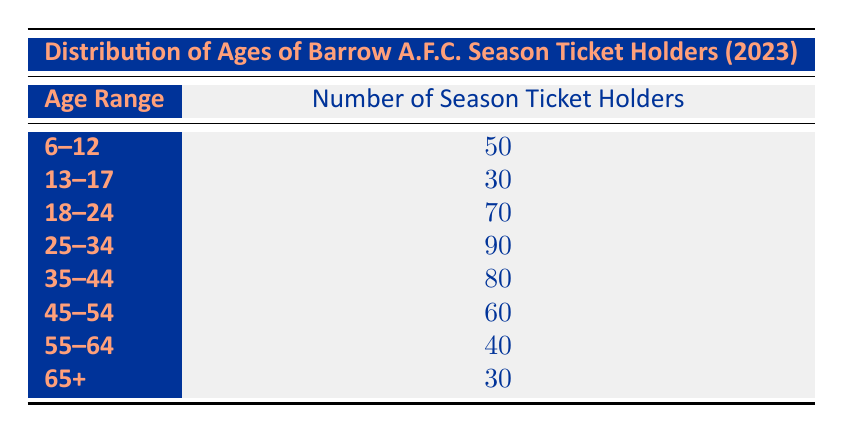What is the total number of season ticket holders aged 25-34? The table indicates that there are 90 season ticket holders in the age range of 25-34. You can find this information directly listed under that age range.
Answer: 90 Which age range has the lowest number of season ticket holders? By reviewing the table, the age range 13-17 has 30 season ticket holders, which is the smallest amount compared to the other age ranges provided.
Answer: 13-17 What is the total number of season ticket holders across all age ranges? To find the total, we add the number of season ticket holders in each age range: 50 + 30 + 70 + 90 + 80 + 60 + 40 + 30 = 450. So, the total number of season ticket holders is 450.
Answer: 450 Is there an equal number of season ticket holders in the age ranges 65+ and 13-17? The table shows that there are 30 season ticket holders in both the 65+ and 13-17 age ranges. Therefore, it is true that they have an equal number of ticket holders.
Answer: Yes What percentage of season ticket holders are aged 55-64 compared to those aged 18-24? The number of season ticket holders aged 55-64 is 40, and for 18-24, it is 70. To find the percentage, we divide 40 by 70 and multiply by 100, resulting in approximately 57.14%. Hence, 55-64 holders make up about 57.14% of those aged 18-24.
Answer: 57.14% 